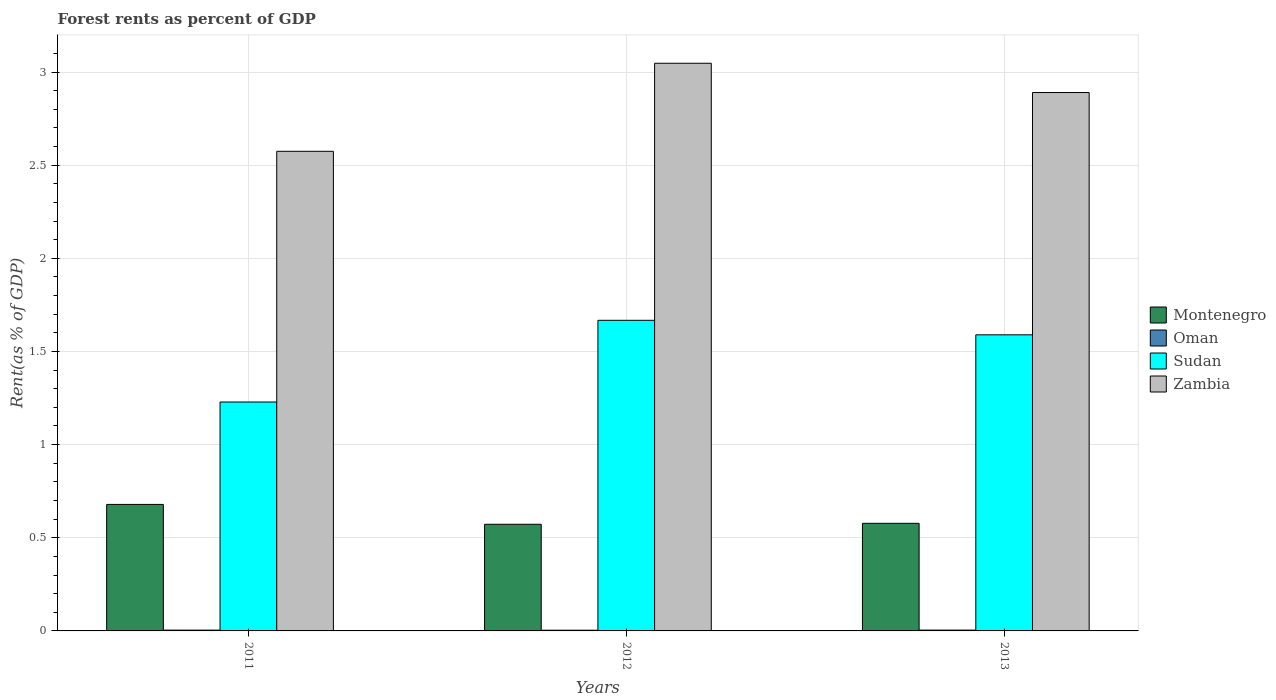How many different coloured bars are there?
Provide a short and direct response. 4. How many groups of bars are there?
Offer a terse response. 3. Are the number of bars per tick equal to the number of legend labels?
Your answer should be very brief. Yes. How many bars are there on the 3rd tick from the left?
Provide a short and direct response. 4. How many bars are there on the 3rd tick from the right?
Your answer should be very brief. 4. In how many cases, is the number of bars for a given year not equal to the number of legend labels?
Ensure brevity in your answer.  0. What is the forest rent in Montenegro in 2012?
Offer a terse response. 0.57. Across all years, what is the maximum forest rent in Sudan?
Make the answer very short. 1.67. Across all years, what is the minimum forest rent in Montenegro?
Offer a very short reply. 0.57. What is the total forest rent in Montenegro in the graph?
Provide a succinct answer. 1.83. What is the difference between the forest rent in Sudan in 2011 and that in 2012?
Give a very brief answer. -0.44. What is the difference between the forest rent in Oman in 2012 and the forest rent in Sudan in 2013?
Your response must be concise. -1.59. What is the average forest rent in Montenegro per year?
Provide a succinct answer. 0.61. In the year 2012, what is the difference between the forest rent in Oman and forest rent in Zambia?
Make the answer very short. -3.04. What is the ratio of the forest rent in Oman in 2012 to that in 2013?
Offer a terse response. 0.87. Is the forest rent in Zambia in 2011 less than that in 2013?
Ensure brevity in your answer.  Yes. Is the difference between the forest rent in Oman in 2011 and 2012 greater than the difference between the forest rent in Zambia in 2011 and 2012?
Make the answer very short. Yes. What is the difference between the highest and the second highest forest rent in Sudan?
Provide a short and direct response. 0.08. What is the difference between the highest and the lowest forest rent in Sudan?
Give a very brief answer. 0.44. What does the 2nd bar from the left in 2013 represents?
Give a very brief answer. Oman. What does the 4th bar from the right in 2011 represents?
Keep it short and to the point. Montenegro. Is it the case that in every year, the sum of the forest rent in Montenegro and forest rent in Oman is greater than the forest rent in Zambia?
Provide a short and direct response. No. How many legend labels are there?
Provide a short and direct response. 4. How are the legend labels stacked?
Provide a succinct answer. Vertical. What is the title of the graph?
Your response must be concise. Forest rents as percent of GDP. Does "Vietnam" appear as one of the legend labels in the graph?
Ensure brevity in your answer.  No. What is the label or title of the Y-axis?
Give a very brief answer. Rent(as % of GDP). What is the Rent(as % of GDP) in Montenegro in 2011?
Offer a terse response. 0.68. What is the Rent(as % of GDP) in Oman in 2011?
Provide a succinct answer. 0. What is the Rent(as % of GDP) in Sudan in 2011?
Ensure brevity in your answer.  1.23. What is the Rent(as % of GDP) of Zambia in 2011?
Offer a terse response. 2.57. What is the Rent(as % of GDP) of Montenegro in 2012?
Your answer should be very brief. 0.57. What is the Rent(as % of GDP) in Oman in 2012?
Offer a very short reply. 0. What is the Rent(as % of GDP) of Sudan in 2012?
Ensure brevity in your answer.  1.67. What is the Rent(as % of GDP) in Zambia in 2012?
Your response must be concise. 3.05. What is the Rent(as % of GDP) in Montenegro in 2013?
Your answer should be very brief. 0.58. What is the Rent(as % of GDP) in Oman in 2013?
Provide a succinct answer. 0. What is the Rent(as % of GDP) of Sudan in 2013?
Offer a terse response. 1.59. What is the Rent(as % of GDP) of Zambia in 2013?
Your answer should be compact. 2.89. Across all years, what is the maximum Rent(as % of GDP) of Montenegro?
Give a very brief answer. 0.68. Across all years, what is the maximum Rent(as % of GDP) of Oman?
Provide a succinct answer. 0. Across all years, what is the maximum Rent(as % of GDP) in Sudan?
Your answer should be compact. 1.67. Across all years, what is the maximum Rent(as % of GDP) of Zambia?
Your answer should be very brief. 3.05. Across all years, what is the minimum Rent(as % of GDP) in Montenegro?
Keep it short and to the point. 0.57. Across all years, what is the minimum Rent(as % of GDP) of Oman?
Provide a succinct answer. 0. Across all years, what is the minimum Rent(as % of GDP) in Sudan?
Provide a succinct answer. 1.23. Across all years, what is the minimum Rent(as % of GDP) of Zambia?
Ensure brevity in your answer.  2.57. What is the total Rent(as % of GDP) of Montenegro in the graph?
Give a very brief answer. 1.83. What is the total Rent(as % of GDP) in Oman in the graph?
Your answer should be very brief. 0.01. What is the total Rent(as % of GDP) of Sudan in the graph?
Your response must be concise. 4.49. What is the total Rent(as % of GDP) of Zambia in the graph?
Keep it short and to the point. 8.51. What is the difference between the Rent(as % of GDP) of Montenegro in 2011 and that in 2012?
Provide a succinct answer. 0.11. What is the difference between the Rent(as % of GDP) of Sudan in 2011 and that in 2012?
Provide a short and direct response. -0.44. What is the difference between the Rent(as % of GDP) in Zambia in 2011 and that in 2012?
Provide a short and direct response. -0.47. What is the difference between the Rent(as % of GDP) in Montenegro in 2011 and that in 2013?
Make the answer very short. 0.1. What is the difference between the Rent(as % of GDP) of Oman in 2011 and that in 2013?
Ensure brevity in your answer.  -0. What is the difference between the Rent(as % of GDP) in Sudan in 2011 and that in 2013?
Your response must be concise. -0.36. What is the difference between the Rent(as % of GDP) in Zambia in 2011 and that in 2013?
Make the answer very short. -0.32. What is the difference between the Rent(as % of GDP) in Montenegro in 2012 and that in 2013?
Make the answer very short. -0.01. What is the difference between the Rent(as % of GDP) in Oman in 2012 and that in 2013?
Your response must be concise. -0. What is the difference between the Rent(as % of GDP) in Sudan in 2012 and that in 2013?
Provide a short and direct response. 0.08. What is the difference between the Rent(as % of GDP) in Zambia in 2012 and that in 2013?
Provide a short and direct response. 0.16. What is the difference between the Rent(as % of GDP) in Montenegro in 2011 and the Rent(as % of GDP) in Oman in 2012?
Ensure brevity in your answer.  0.68. What is the difference between the Rent(as % of GDP) of Montenegro in 2011 and the Rent(as % of GDP) of Sudan in 2012?
Provide a short and direct response. -0.99. What is the difference between the Rent(as % of GDP) of Montenegro in 2011 and the Rent(as % of GDP) of Zambia in 2012?
Offer a terse response. -2.37. What is the difference between the Rent(as % of GDP) of Oman in 2011 and the Rent(as % of GDP) of Sudan in 2012?
Offer a terse response. -1.66. What is the difference between the Rent(as % of GDP) of Oman in 2011 and the Rent(as % of GDP) of Zambia in 2012?
Give a very brief answer. -3.04. What is the difference between the Rent(as % of GDP) of Sudan in 2011 and the Rent(as % of GDP) of Zambia in 2012?
Your answer should be very brief. -1.82. What is the difference between the Rent(as % of GDP) of Montenegro in 2011 and the Rent(as % of GDP) of Oman in 2013?
Your answer should be very brief. 0.67. What is the difference between the Rent(as % of GDP) in Montenegro in 2011 and the Rent(as % of GDP) in Sudan in 2013?
Your answer should be compact. -0.91. What is the difference between the Rent(as % of GDP) in Montenegro in 2011 and the Rent(as % of GDP) in Zambia in 2013?
Offer a terse response. -2.21. What is the difference between the Rent(as % of GDP) of Oman in 2011 and the Rent(as % of GDP) of Sudan in 2013?
Keep it short and to the point. -1.58. What is the difference between the Rent(as % of GDP) in Oman in 2011 and the Rent(as % of GDP) in Zambia in 2013?
Provide a succinct answer. -2.89. What is the difference between the Rent(as % of GDP) of Sudan in 2011 and the Rent(as % of GDP) of Zambia in 2013?
Ensure brevity in your answer.  -1.66. What is the difference between the Rent(as % of GDP) of Montenegro in 2012 and the Rent(as % of GDP) of Oman in 2013?
Keep it short and to the point. 0.57. What is the difference between the Rent(as % of GDP) in Montenegro in 2012 and the Rent(as % of GDP) in Sudan in 2013?
Your response must be concise. -1.02. What is the difference between the Rent(as % of GDP) of Montenegro in 2012 and the Rent(as % of GDP) of Zambia in 2013?
Keep it short and to the point. -2.32. What is the difference between the Rent(as % of GDP) of Oman in 2012 and the Rent(as % of GDP) of Sudan in 2013?
Ensure brevity in your answer.  -1.59. What is the difference between the Rent(as % of GDP) of Oman in 2012 and the Rent(as % of GDP) of Zambia in 2013?
Offer a very short reply. -2.89. What is the difference between the Rent(as % of GDP) in Sudan in 2012 and the Rent(as % of GDP) in Zambia in 2013?
Provide a succinct answer. -1.22. What is the average Rent(as % of GDP) of Montenegro per year?
Your answer should be very brief. 0.61. What is the average Rent(as % of GDP) of Oman per year?
Give a very brief answer. 0. What is the average Rent(as % of GDP) of Sudan per year?
Make the answer very short. 1.5. What is the average Rent(as % of GDP) in Zambia per year?
Make the answer very short. 2.84. In the year 2011, what is the difference between the Rent(as % of GDP) in Montenegro and Rent(as % of GDP) in Oman?
Make the answer very short. 0.67. In the year 2011, what is the difference between the Rent(as % of GDP) in Montenegro and Rent(as % of GDP) in Sudan?
Make the answer very short. -0.55. In the year 2011, what is the difference between the Rent(as % of GDP) of Montenegro and Rent(as % of GDP) of Zambia?
Your answer should be compact. -1.9. In the year 2011, what is the difference between the Rent(as % of GDP) in Oman and Rent(as % of GDP) in Sudan?
Your response must be concise. -1.22. In the year 2011, what is the difference between the Rent(as % of GDP) in Oman and Rent(as % of GDP) in Zambia?
Give a very brief answer. -2.57. In the year 2011, what is the difference between the Rent(as % of GDP) in Sudan and Rent(as % of GDP) in Zambia?
Give a very brief answer. -1.35. In the year 2012, what is the difference between the Rent(as % of GDP) in Montenegro and Rent(as % of GDP) in Oman?
Offer a very short reply. 0.57. In the year 2012, what is the difference between the Rent(as % of GDP) of Montenegro and Rent(as % of GDP) of Sudan?
Ensure brevity in your answer.  -1.09. In the year 2012, what is the difference between the Rent(as % of GDP) in Montenegro and Rent(as % of GDP) in Zambia?
Your answer should be compact. -2.47. In the year 2012, what is the difference between the Rent(as % of GDP) in Oman and Rent(as % of GDP) in Sudan?
Make the answer very short. -1.66. In the year 2012, what is the difference between the Rent(as % of GDP) in Oman and Rent(as % of GDP) in Zambia?
Offer a very short reply. -3.04. In the year 2012, what is the difference between the Rent(as % of GDP) in Sudan and Rent(as % of GDP) in Zambia?
Keep it short and to the point. -1.38. In the year 2013, what is the difference between the Rent(as % of GDP) in Montenegro and Rent(as % of GDP) in Oman?
Ensure brevity in your answer.  0.57. In the year 2013, what is the difference between the Rent(as % of GDP) of Montenegro and Rent(as % of GDP) of Sudan?
Your response must be concise. -1.01. In the year 2013, what is the difference between the Rent(as % of GDP) in Montenegro and Rent(as % of GDP) in Zambia?
Give a very brief answer. -2.31. In the year 2013, what is the difference between the Rent(as % of GDP) of Oman and Rent(as % of GDP) of Sudan?
Offer a very short reply. -1.58. In the year 2013, what is the difference between the Rent(as % of GDP) of Oman and Rent(as % of GDP) of Zambia?
Make the answer very short. -2.89. In the year 2013, what is the difference between the Rent(as % of GDP) of Sudan and Rent(as % of GDP) of Zambia?
Give a very brief answer. -1.3. What is the ratio of the Rent(as % of GDP) in Montenegro in 2011 to that in 2012?
Provide a succinct answer. 1.19. What is the ratio of the Rent(as % of GDP) of Oman in 2011 to that in 2012?
Your response must be concise. 1.13. What is the ratio of the Rent(as % of GDP) of Sudan in 2011 to that in 2012?
Offer a very short reply. 0.74. What is the ratio of the Rent(as % of GDP) in Zambia in 2011 to that in 2012?
Your answer should be very brief. 0.84. What is the ratio of the Rent(as % of GDP) in Montenegro in 2011 to that in 2013?
Your answer should be very brief. 1.18. What is the ratio of the Rent(as % of GDP) of Oman in 2011 to that in 2013?
Make the answer very short. 0.98. What is the ratio of the Rent(as % of GDP) in Sudan in 2011 to that in 2013?
Provide a short and direct response. 0.77. What is the ratio of the Rent(as % of GDP) of Zambia in 2011 to that in 2013?
Your answer should be very brief. 0.89. What is the ratio of the Rent(as % of GDP) of Montenegro in 2012 to that in 2013?
Give a very brief answer. 0.99. What is the ratio of the Rent(as % of GDP) in Oman in 2012 to that in 2013?
Your answer should be compact. 0.87. What is the ratio of the Rent(as % of GDP) in Sudan in 2012 to that in 2013?
Offer a terse response. 1.05. What is the ratio of the Rent(as % of GDP) of Zambia in 2012 to that in 2013?
Offer a terse response. 1.05. What is the difference between the highest and the second highest Rent(as % of GDP) in Montenegro?
Offer a very short reply. 0.1. What is the difference between the highest and the second highest Rent(as % of GDP) of Sudan?
Make the answer very short. 0.08. What is the difference between the highest and the second highest Rent(as % of GDP) of Zambia?
Offer a terse response. 0.16. What is the difference between the highest and the lowest Rent(as % of GDP) of Montenegro?
Offer a terse response. 0.11. What is the difference between the highest and the lowest Rent(as % of GDP) in Oman?
Provide a succinct answer. 0. What is the difference between the highest and the lowest Rent(as % of GDP) of Sudan?
Your answer should be compact. 0.44. What is the difference between the highest and the lowest Rent(as % of GDP) of Zambia?
Provide a short and direct response. 0.47. 